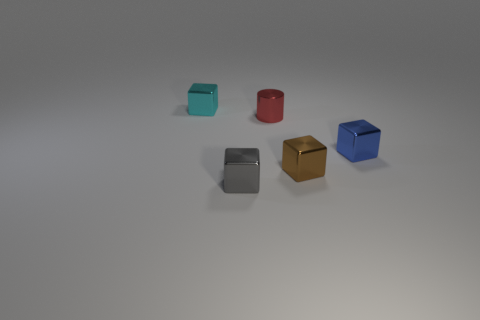Subtract all gray cubes. How many cubes are left? 3 Subtract all gray cubes. How many cubes are left? 3 Subtract 1 cubes. How many cubes are left? 3 Add 5 large cyan spheres. How many objects exist? 10 Subtract all cylinders. How many objects are left? 4 Add 4 blue metal things. How many blue metal things exist? 5 Subtract 0 brown spheres. How many objects are left? 5 Subtract all cyan cylinders. Subtract all purple balls. How many cylinders are left? 1 Subtract all gray metal cubes. Subtract all tiny cyan metallic cubes. How many objects are left? 3 Add 4 tiny cyan blocks. How many tiny cyan blocks are left? 5 